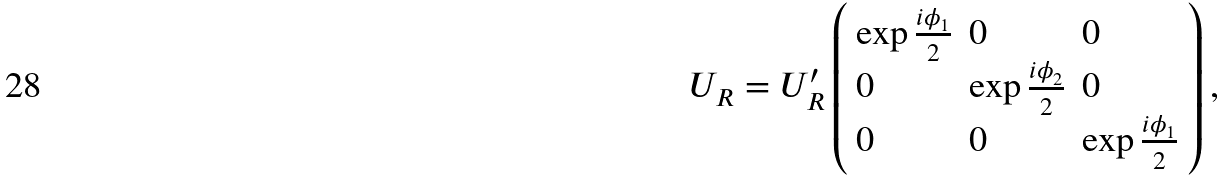<formula> <loc_0><loc_0><loc_500><loc_500>U _ { R } = U _ { R } ^ { \prime } \left ( \begin{array} { l l l } { { \exp \frac { i \phi _ { 1 } } { 2 } } } & { 0 } & { 0 } \\ { 0 } & { { \exp \frac { i \phi _ { 2 } } { 2 } } } & { 0 } \\ { 0 } & { 0 } & { { \exp \frac { i \phi _ { 1 } } { 2 } } } \end{array} \right ) ,</formula> 